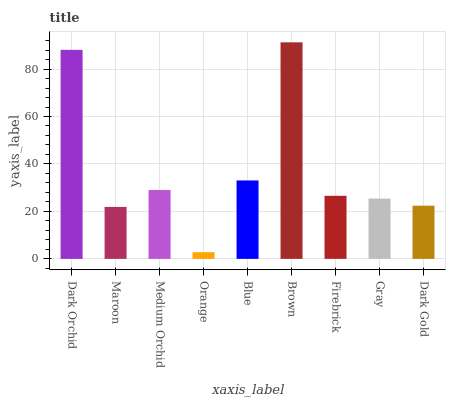Is Orange the minimum?
Answer yes or no. Yes. Is Brown the maximum?
Answer yes or no. Yes. Is Maroon the minimum?
Answer yes or no. No. Is Maroon the maximum?
Answer yes or no. No. Is Dark Orchid greater than Maroon?
Answer yes or no. Yes. Is Maroon less than Dark Orchid?
Answer yes or no. Yes. Is Maroon greater than Dark Orchid?
Answer yes or no. No. Is Dark Orchid less than Maroon?
Answer yes or no. No. Is Firebrick the high median?
Answer yes or no. Yes. Is Firebrick the low median?
Answer yes or no. Yes. Is Dark Gold the high median?
Answer yes or no. No. Is Orange the low median?
Answer yes or no. No. 